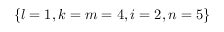<formula> <loc_0><loc_0><loc_500><loc_500>\left \{ l = 1 , k = m = 4 , i = 2 , n = 5 \right \}</formula> 